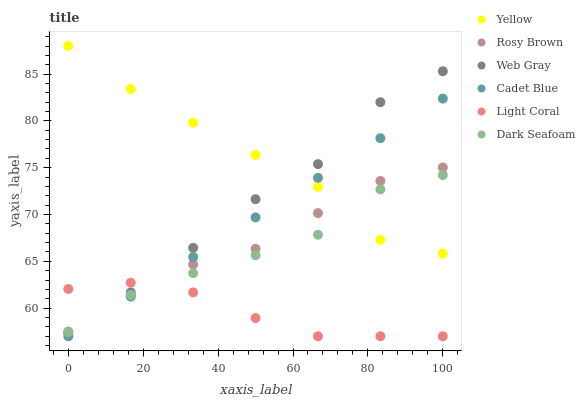Does Light Coral have the minimum area under the curve?
Answer yes or no. Yes. Does Yellow have the maximum area under the curve?
Answer yes or no. Yes. Does Rosy Brown have the minimum area under the curve?
Answer yes or no. No. Does Rosy Brown have the maximum area under the curve?
Answer yes or no. No. Is Cadet Blue the smoothest?
Answer yes or no. Yes. Is Web Gray the roughest?
Answer yes or no. Yes. Is Rosy Brown the smoothest?
Answer yes or no. No. Is Rosy Brown the roughest?
Answer yes or no. No. Does Cadet Blue have the lowest value?
Answer yes or no. Yes. Does Rosy Brown have the lowest value?
Answer yes or no. No. Does Yellow have the highest value?
Answer yes or no. Yes. Does Rosy Brown have the highest value?
Answer yes or no. No. Is Light Coral less than Yellow?
Answer yes or no. Yes. Is Yellow greater than Light Coral?
Answer yes or no. Yes. Does Cadet Blue intersect Dark Seafoam?
Answer yes or no. Yes. Is Cadet Blue less than Dark Seafoam?
Answer yes or no. No. Is Cadet Blue greater than Dark Seafoam?
Answer yes or no. No. Does Light Coral intersect Yellow?
Answer yes or no. No. 